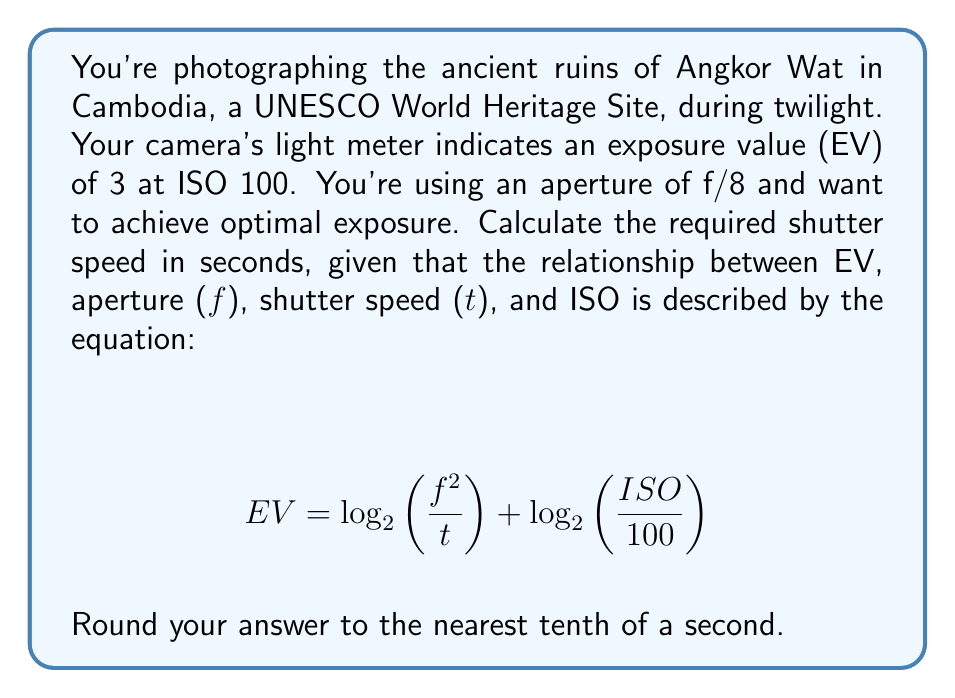Solve this math problem. Let's approach this step-by-step:

1) We're given:
   - EV = 3
   - f = 8
   - ISO = 100

2) We need to solve for t (shutter speed in seconds).

3) Since ISO = 100, the $\log_2\left(\frac{ISO}{100}\right)$ term becomes zero:

   $$ 3 = \log_2\left(\frac{8^2}{t}\right) + 0 $$

4) Simplify:

   $$ 3 = \log_2\left(\frac{64}{t}\right) $$

5) Apply $2^x$ to both sides:

   $$ 2^3 = \frac{64}{t} $$

6) Simplify:

   $$ 8 = \frac{64}{t} $$

7) Multiply both sides by t:

   $$ 8t = 64 $$

8) Solve for t:

   $$ t = \frac{64}{8} = 8 $$

Therefore, the required shutter speed is 8 seconds.
Answer: 8.0 seconds 